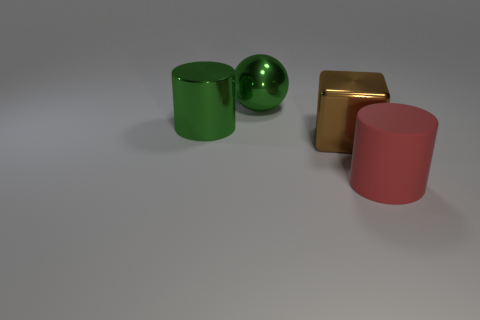The other metal object that is the same shape as the large red thing is what color?
Your answer should be compact. Green. Is there any other thing that has the same shape as the big brown metallic thing?
Your answer should be compact. No. Do the large rubber thing and the big green metallic object that is in front of the green ball have the same shape?
Your response must be concise. Yes. What is the material of the big brown block?
Your answer should be compact. Metal. There is another metallic object that is the same shape as the large red thing; what size is it?
Ensure brevity in your answer.  Large. How many other objects are there of the same material as the large red cylinder?
Your response must be concise. 0. Is the material of the red object the same as the green object that is on the right side of the big green metal cylinder?
Provide a short and direct response. No. Are there fewer red rubber things that are behind the green sphere than red things in front of the large matte thing?
Offer a very short reply. No. What color is the big cylinder that is behind the large matte thing?
Make the answer very short. Green. How many other things are the same color as the big matte object?
Offer a very short reply. 0. 